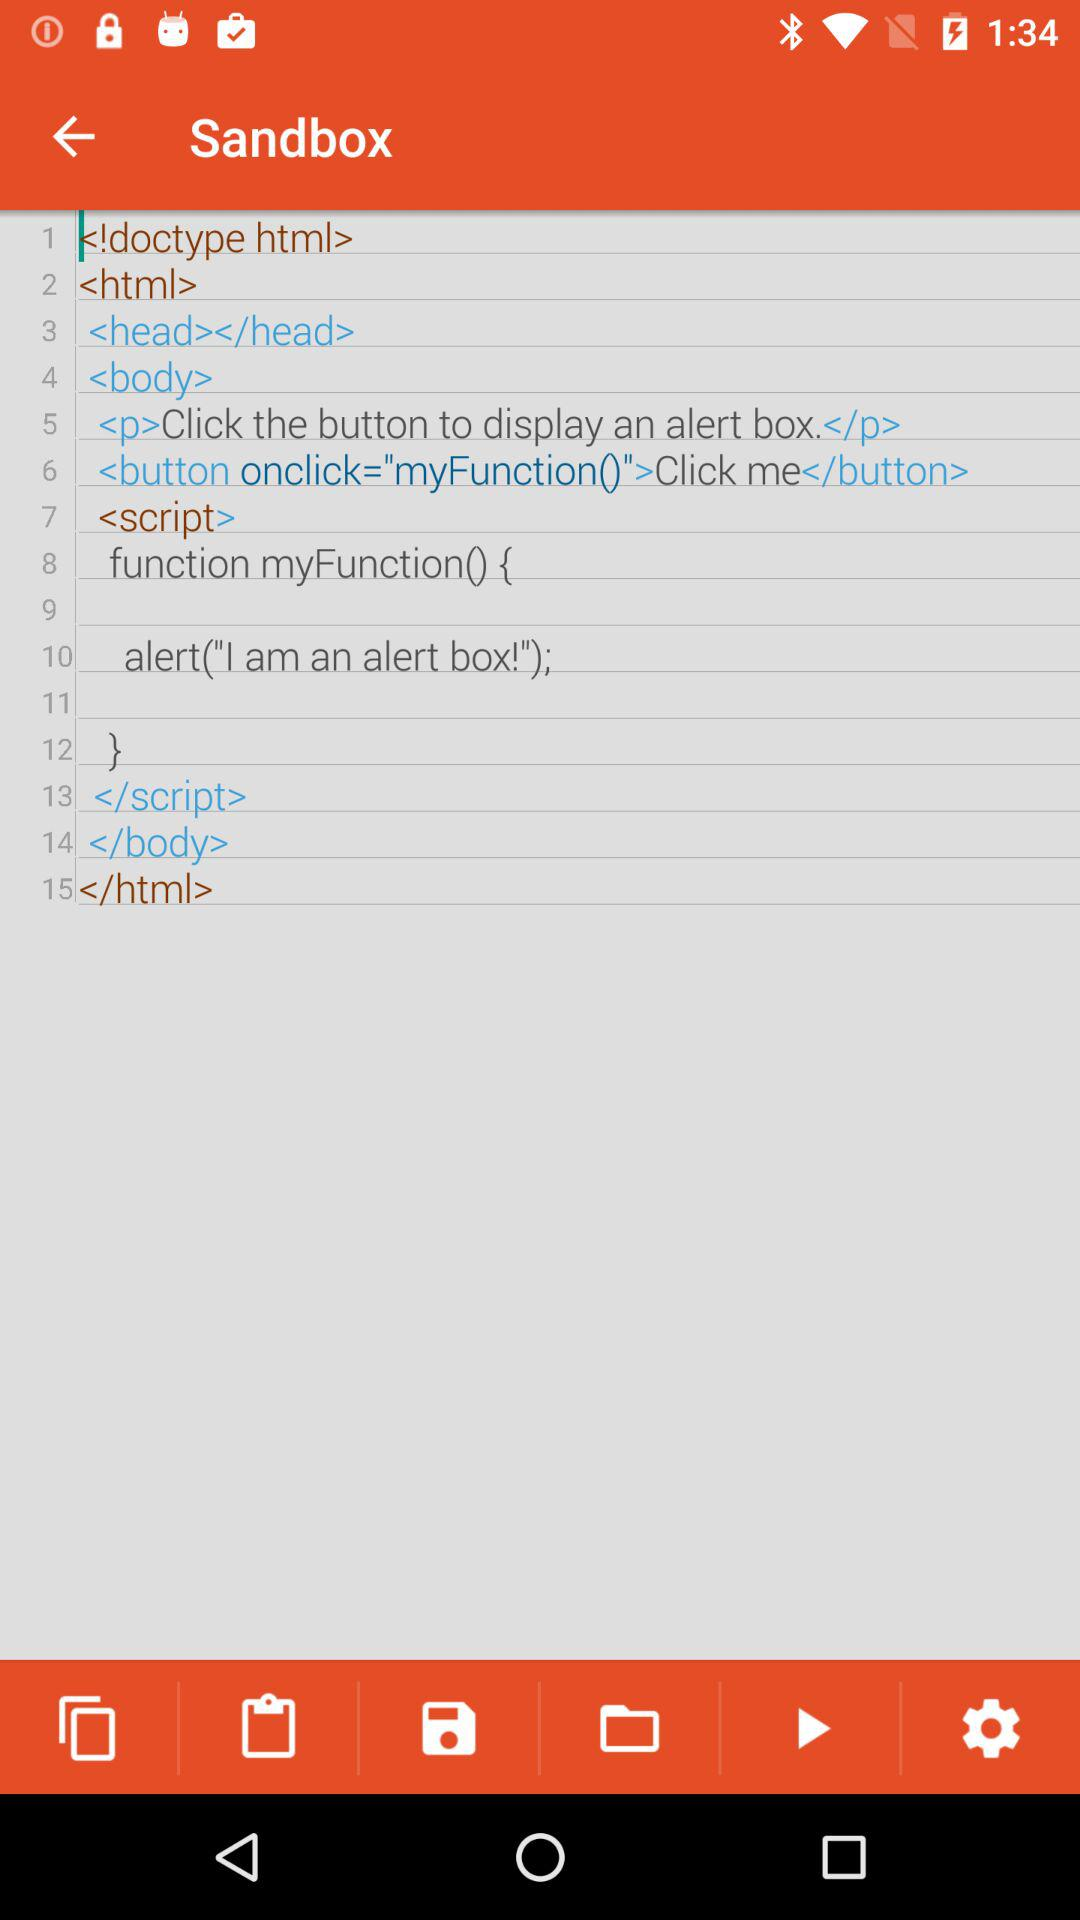How many lines of code are there in the text editor?
Answer the question using a single word or phrase. 15 